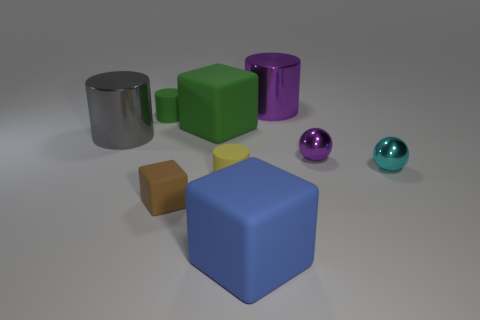Subtract all gray metallic cylinders. How many cylinders are left? 3 Add 1 green matte objects. How many objects exist? 10 Subtract all green cylinders. How many cylinders are left? 3 Subtract 2 cylinders. How many cylinders are left? 2 Subtract all green blocks. Subtract all green balls. How many blocks are left? 2 Subtract all brown matte things. Subtract all green matte blocks. How many objects are left? 7 Add 3 large blue cubes. How many large blue cubes are left? 4 Add 6 big blocks. How many big blocks exist? 8 Subtract 0 blue cylinders. How many objects are left? 9 Subtract all balls. How many objects are left? 7 